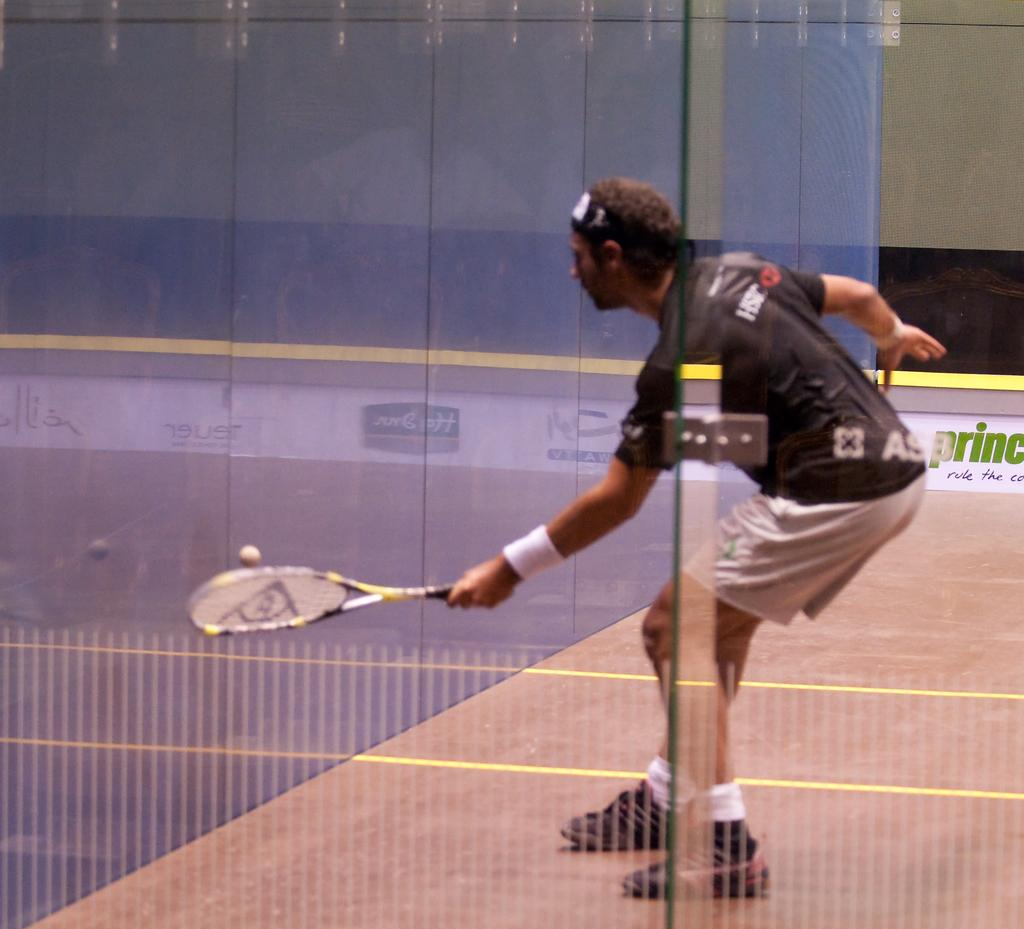Who is present in the image? There is a person in the image. What is the person doing in the image? The person is standing and hitting a ball. What object is the person holding in their left hand? The person is holding a tennis racket in their left hand. Where does the scene take place? The scene takes place in a playground. What type of needle can be seen in the image? There is no needle present in the image. Can you see any sails in the image? There are no sails present in the image. 